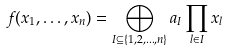Convert formula to latex. <formula><loc_0><loc_0><loc_500><loc_500>f ( x _ { 1 } , \dots , x _ { n } ) = \bigoplus _ { I \subseteq \{ 1 , 2 , \dots , n \} } a _ { I } \prod _ { l \in I } x _ { l }</formula> 